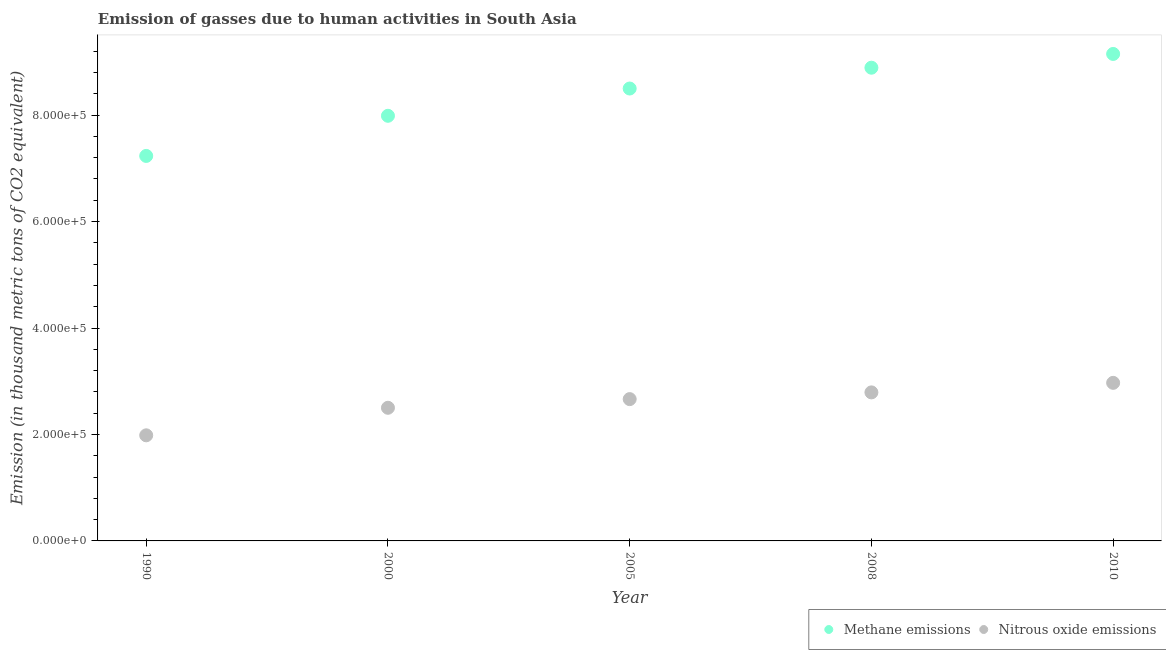How many different coloured dotlines are there?
Provide a succinct answer. 2. Is the number of dotlines equal to the number of legend labels?
Make the answer very short. Yes. What is the amount of methane emissions in 1990?
Provide a succinct answer. 7.23e+05. Across all years, what is the maximum amount of methane emissions?
Provide a succinct answer. 9.15e+05. Across all years, what is the minimum amount of methane emissions?
Give a very brief answer. 7.23e+05. In which year was the amount of methane emissions minimum?
Your answer should be compact. 1990. What is the total amount of nitrous oxide emissions in the graph?
Give a very brief answer. 1.29e+06. What is the difference between the amount of nitrous oxide emissions in 2005 and that in 2008?
Give a very brief answer. -1.26e+04. What is the difference between the amount of methane emissions in 2008 and the amount of nitrous oxide emissions in 2005?
Your answer should be compact. 6.23e+05. What is the average amount of methane emissions per year?
Offer a terse response. 8.35e+05. In the year 2005, what is the difference between the amount of methane emissions and amount of nitrous oxide emissions?
Ensure brevity in your answer.  5.84e+05. In how many years, is the amount of nitrous oxide emissions greater than 80000 thousand metric tons?
Provide a short and direct response. 5. What is the ratio of the amount of nitrous oxide emissions in 2008 to that in 2010?
Your answer should be very brief. 0.94. What is the difference between the highest and the second highest amount of methane emissions?
Provide a short and direct response. 2.59e+04. What is the difference between the highest and the lowest amount of nitrous oxide emissions?
Offer a very short reply. 9.86e+04. In how many years, is the amount of nitrous oxide emissions greater than the average amount of nitrous oxide emissions taken over all years?
Provide a succinct answer. 3. Is the sum of the amount of nitrous oxide emissions in 1990 and 2005 greater than the maximum amount of methane emissions across all years?
Make the answer very short. No. How many dotlines are there?
Your response must be concise. 2. How many years are there in the graph?
Offer a terse response. 5. What is the difference between two consecutive major ticks on the Y-axis?
Your answer should be very brief. 2.00e+05. Are the values on the major ticks of Y-axis written in scientific E-notation?
Provide a short and direct response. Yes. Does the graph contain any zero values?
Offer a terse response. No. Where does the legend appear in the graph?
Your answer should be compact. Bottom right. How are the legend labels stacked?
Your response must be concise. Horizontal. What is the title of the graph?
Give a very brief answer. Emission of gasses due to human activities in South Asia. Does "Register a business" appear as one of the legend labels in the graph?
Offer a very short reply. No. What is the label or title of the Y-axis?
Provide a succinct answer. Emission (in thousand metric tons of CO2 equivalent). What is the Emission (in thousand metric tons of CO2 equivalent) of Methane emissions in 1990?
Offer a terse response. 7.23e+05. What is the Emission (in thousand metric tons of CO2 equivalent) of Nitrous oxide emissions in 1990?
Give a very brief answer. 1.98e+05. What is the Emission (in thousand metric tons of CO2 equivalent) of Methane emissions in 2000?
Offer a terse response. 7.99e+05. What is the Emission (in thousand metric tons of CO2 equivalent) in Nitrous oxide emissions in 2000?
Make the answer very short. 2.50e+05. What is the Emission (in thousand metric tons of CO2 equivalent) in Methane emissions in 2005?
Keep it short and to the point. 8.50e+05. What is the Emission (in thousand metric tons of CO2 equivalent) in Nitrous oxide emissions in 2005?
Provide a succinct answer. 2.66e+05. What is the Emission (in thousand metric tons of CO2 equivalent) in Methane emissions in 2008?
Make the answer very short. 8.89e+05. What is the Emission (in thousand metric tons of CO2 equivalent) in Nitrous oxide emissions in 2008?
Your answer should be compact. 2.79e+05. What is the Emission (in thousand metric tons of CO2 equivalent) of Methane emissions in 2010?
Keep it short and to the point. 9.15e+05. What is the Emission (in thousand metric tons of CO2 equivalent) of Nitrous oxide emissions in 2010?
Your answer should be very brief. 2.97e+05. Across all years, what is the maximum Emission (in thousand metric tons of CO2 equivalent) in Methane emissions?
Keep it short and to the point. 9.15e+05. Across all years, what is the maximum Emission (in thousand metric tons of CO2 equivalent) in Nitrous oxide emissions?
Offer a terse response. 2.97e+05. Across all years, what is the minimum Emission (in thousand metric tons of CO2 equivalent) in Methane emissions?
Your answer should be very brief. 7.23e+05. Across all years, what is the minimum Emission (in thousand metric tons of CO2 equivalent) of Nitrous oxide emissions?
Offer a very short reply. 1.98e+05. What is the total Emission (in thousand metric tons of CO2 equivalent) in Methane emissions in the graph?
Give a very brief answer. 4.18e+06. What is the total Emission (in thousand metric tons of CO2 equivalent) in Nitrous oxide emissions in the graph?
Your answer should be compact. 1.29e+06. What is the difference between the Emission (in thousand metric tons of CO2 equivalent) of Methane emissions in 1990 and that in 2000?
Provide a short and direct response. -7.54e+04. What is the difference between the Emission (in thousand metric tons of CO2 equivalent) in Nitrous oxide emissions in 1990 and that in 2000?
Your answer should be very brief. -5.17e+04. What is the difference between the Emission (in thousand metric tons of CO2 equivalent) in Methane emissions in 1990 and that in 2005?
Make the answer very short. -1.27e+05. What is the difference between the Emission (in thousand metric tons of CO2 equivalent) of Nitrous oxide emissions in 1990 and that in 2005?
Ensure brevity in your answer.  -6.80e+04. What is the difference between the Emission (in thousand metric tons of CO2 equivalent) of Methane emissions in 1990 and that in 2008?
Give a very brief answer. -1.66e+05. What is the difference between the Emission (in thousand metric tons of CO2 equivalent) in Nitrous oxide emissions in 1990 and that in 2008?
Your answer should be compact. -8.07e+04. What is the difference between the Emission (in thousand metric tons of CO2 equivalent) in Methane emissions in 1990 and that in 2010?
Offer a terse response. -1.92e+05. What is the difference between the Emission (in thousand metric tons of CO2 equivalent) of Nitrous oxide emissions in 1990 and that in 2010?
Your answer should be compact. -9.86e+04. What is the difference between the Emission (in thousand metric tons of CO2 equivalent) of Methane emissions in 2000 and that in 2005?
Keep it short and to the point. -5.12e+04. What is the difference between the Emission (in thousand metric tons of CO2 equivalent) in Nitrous oxide emissions in 2000 and that in 2005?
Provide a short and direct response. -1.63e+04. What is the difference between the Emission (in thousand metric tons of CO2 equivalent) of Methane emissions in 2000 and that in 2008?
Provide a short and direct response. -9.03e+04. What is the difference between the Emission (in thousand metric tons of CO2 equivalent) in Nitrous oxide emissions in 2000 and that in 2008?
Offer a very short reply. -2.89e+04. What is the difference between the Emission (in thousand metric tons of CO2 equivalent) of Methane emissions in 2000 and that in 2010?
Your answer should be very brief. -1.16e+05. What is the difference between the Emission (in thousand metric tons of CO2 equivalent) of Nitrous oxide emissions in 2000 and that in 2010?
Offer a terse response. -4.68e+04. What is the difference between the Emission (in thousand metric tons of CO2 equivalent) in Methane emissions in 2005 and that in 2008?
Keep it short and to the point. -3.91e+04. What is the difference between the Emission (in thousand metric tons of CO2 equivalent) in Nitrous oxide emissions in 2005 and that in 2008?
Keep it short and to the point. -1.26e+04. What is the difference between the Emission (in thousand metric tons of CO2 equivalent) in Methane emissions in 2005 and that in 2010?
Your answer should be compact. -6.50e+04. What is the difference between the Emission (in thousand metric tons of CO2 equivalent) of Nitrous oxide emissions in 2005 and that in 2010?
Offer a very short reply. -3.06e+04. What is the difference between the Emission (in thousand metric tons of CO2 equivalent) in Methane emissions in 2008 and that in 2010?
Offer a very short reply. -2.59e+04. What is the difference between the Emission (in thousand metric tons of CO2 equivalent) in Nitrous oxide emissions in 2008 and that in 2010?
Provide a succinct answer. -1.79e+04. What is the difference between the Emission (in thousand metric tons of CO2 equivalent) of Methane emissions in 1990 and the Emission (in thousand metric tons of CO2 equivalent) of Nitrous oxide emissions in 2000?
Provide a succinct answer. 4.73e+05. What is the difference between the Emission (in thousand metric tons of CO2 equivalent) in Methane emissions in 1990 and the Emission (in thousand metric tons of CO2 equivalent) in Nitrous oxide emissions in 2005?
Keep it short and to the point. 4.57e+05. What is the difference between the Emission (in thousand metric tons of CO2 equivalent) in Methane emissions in 1990 and the Emission (in thousand metric tons of CO2 equivalent) in Nitrous oxide emissions in 2008?
Provide a short and direct response. 4.44e+05. What is the difference between the Emission (in thousand metric tons of CO2 equivalent) of Methane emissions in 1990 and the Emission (in thousand metric tons of CO2 equivalent) of Nitrous oxide emissions in 2010?
Offer a terse response. 4.26e+05. What is the difference between the Emission (in thousand metric tons of CO2 equivalent) of Methane emissions in 2000 and the Emission (in thousand metric tons of CO2 equivalent) of Nitrous oxide emissions in 2005?
Provide a succinct answer. 5.32e+05. What is the difference between the Emission (in thousand metric tons of CO2 equivalent) in Methane emissions in 2000 and the Emission (in thousand metric tons of CO2 equivalent) in Nitrous oxide emissions in 2008?
Your answer should be compact. 5.20e+05. What is the difference between the Emission (in thousand metric tons of CO2 equivalent) of Methane emissions in 2000 and the Emission (in thousand metric tons of CO2 equivalent) of Nitrous oxide emissions in 2010?
Offer a terse response. 5.02e+05. What is the difference between the Emission (in thousand metric tons of CO2 equivalent) in Methane emissions in 2005 and the Emission (in thousand metric tons of CO2 equivalent) in Nitrous oxide emissions in 2008?
Give a very brief answer. 5.71e+05. What is the difference between the Emission (in thousand metric tons of CO2 equivalent) of Methane emissions in 2005 and the Emission (in thousand metric tons of CO2 equivalent) of Nitrous oxide emissions in 2010?
Offer a terse response. 5.53e+05. What is the difference between the Emission (in thousand metric tons of CO2 equivalent) in Methane emissions in 2008 and the Emission (in thousand metric tons of CO2 equivalent) in Nitrous oxide emissions in 2010?
Offer a terse response. 5.92e+05. What is the average Emission (in thousand metric tons of CO2 equivalent) of Methane emissions per year?
Offer a very short reply. 8.35e+05. What is the average Emission (in thousand metric tons of CO2 equivalent) in Nitrous oxide emissions per year?
Keep it short and to the point. 2.58e+05. In the year 1990, what is the difference between the Emission (in thousand metric tons of CO2 equivalent) in Methane emissions and Emission (in thousand metric tons of CO2 equivalent) in Nitrous oxide emissions?
Provide a short and direct response. 5.25e+05. In the year 2000, what is the difference between the Emission (in thousand metric tons of CO2 equivalent) of Methane emissions and Emission (in thousand metric tons of CO2 equivalent) of Nitrous oxide emissions?
Make the answer very short. 5.49e+05. In the year 2005, what is the difference between the Emission (in thousand metric tons of CO2 equivalent) in Methane emissions and Emission (in thousand metric tons of CO2 equivalent) in Nitrous oxide emissions?
Your answer should be very brief. 5.84e+05. In the year 2008, what is the difference between the Emission (in thousand metric tons of CO2 equivalent) in Methane emissions and Emission (in thousand metric tons of CO2 equivalent) in Nitrous oxide emissions?
Offer a terse response. 6.10e+05. In the year 2010, what is the difference between the Emission (in thousand metric tons of CO2 equivalent) of Methane emissions and Emission (in thousand metric tons of CO2 equivalent) of Nitrous oxide emissions?
Your response must be concise. 6.18e+05. What is the ratio of the Emission (in thousand metric tons of CO2 equivalent) of Methane emissions in 1990 to that in 2000?
Keep it short and to the point. 0.91. What is the ratio of the Emission (in thousand metric tons of CO2 equivalent) in Nitrous oxide emissions in 1990 to that in 2000?
Offer a very short reply. 0.79. What is the ratio of the Emission (in thousand metric tons of CO2 equivalent) of Methane emissions in 1990 to that in 2005?
Make the answer very short. 0.85. What is the ratio of the Emission (in thousand metric tons of CO2 equivalent) of Nitrous oxide emissions in 1990 to that in 2005?
Give a very brief answer. 0.74. What is the ratio of the Emission (in thousand metric tons of CO2 equivalent) of Methane emissions in 1990 to that in 2008?
Offer a terse response. 0.81. What is the ratio of the Emission (in thousand metric tons of CO2 equivalent) in Nitrous oxide emissions in 1990 to that in 2008?
Keep it short and to the point. 0.71. What is the ratio of the Emission (in thousand metric tons of CO2 equivalent) of Methane emissions in 1990 to that in 2010?
Provide a succinct answer. 0.79. What is the ratio of the Emission (in thousand metric tons of CO2 equivalent) of Nitrous oxide emissions in 1990 to that in 2010?
Give a very brief answer. 0.67. What is the ratio of the Emission (in thousand metric tons of CO2 equivalent) in Methane emissions in 2000 to that in 2005?
Ensure brevity in your answer.  0.94. What is the ratio of the Emission (in thousand metric tons of CO2 equivalent) of Nitrous oxide emissions in 2000 to that in 2005?
Provide a short and direct response. 0.94. What is the ratio of the Emission (in thousand metric tons of CO2 equivalent) of Methane emissions in 2000 to that in 2008?
Provide a succinct answer. 0.9. What is the ratio of the Emission (in thousand metric tons of CO2 equivalent) in Nitrous oxide emissions in 2000 to that in 2008?
Your answer should be compact. 0.9. What is the ratio of the Emission (in thousand metric tons of CO2 equivalent) of Methane emissions in 2000 to that in 2010?
Offer a very short reply. 0.87. What is the ratio of the Emission (in thousand metric tons of CO2 equivalent) in Nitrous oxide emissions in 2000 to that in 2010?
Provide a short and direct response. 0.84. What is the ratio of the Emission (in thousand metric tons of CO2 equivalent) of Methane emissions in 2005 to that in 2008?
Your response must be concise. 0.96. What is the ratio of the Emission (in thousand metric tons of CO2 equivalent) of Nitrous oxide emissions in 2005 to that in 2008?
Your answer should be compact. 0.95. What is the ratio of the Emission (in thousand metric tons of CO2 equivalent) in Methane emissions in 2005 to that in 2010?
Your answer should be compact. 0.93. What is the ratio of the Emission (in thousand metric tons of CO2 equivalent) in Nitrous oxide emissions in 2005 to that in 2010?
Your answer should be very brief. 0.9. What is the ratio of the Emission (in thousand metric tons of CO2 equivalent) of Methane emissions in 2008 to that in 2010?
Offer a terse response. 0.97. What is the ratio of the Emission (in thousand metric tons of CO2 equivalent) in Nitrous oxide emissions in 2008 to that in 2010?
Make the answer very short. 0.94. What is the difference between the highest and the second highest Emission (in thousand metric tons of CO2 equivalent) of Methane emissions?
Provide a short and direct response. 2.59e+04. What is the difference between the highest and the second highest Emission (in thousand metric tons of CO2 equivalent) of Nitrous oxide emissions?
Provide a short and direct response. 1.79e+04. What is the difference between the highest and the lowest Emission (in thousand metric tons of CO2 equivalent) of Methane emissions?
Your answer should be very brief. 1.92e+05. What is the difference between the highest and the lowest Emission (in thousand metric tons of CO2 equivalent) in Nitrous oxide emissions?
Provide a short and direct response. 9.86e+04. 